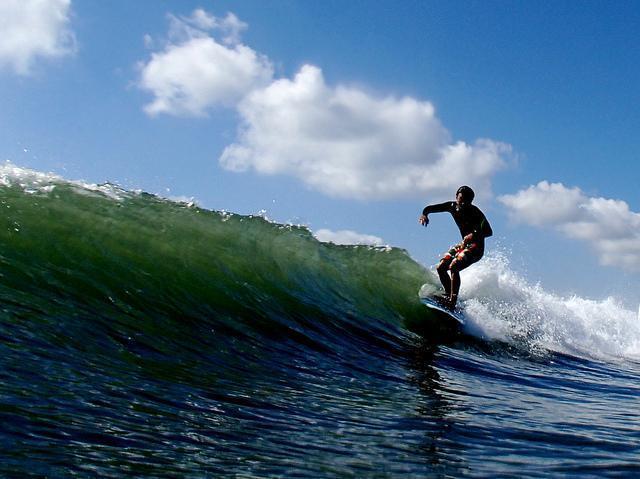How many wheels are visible?
Give a very brief answer. 0. How many clear bottles of wine are on the table?
Give a very brief answer. 0. 